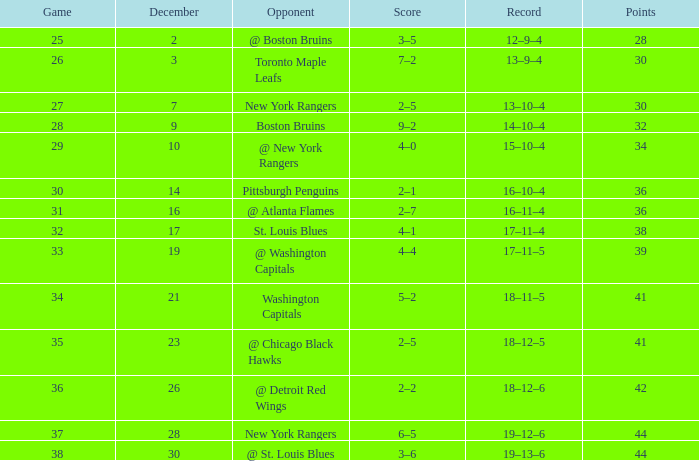What score consists of 36 points and a 30-game? 2–1. 